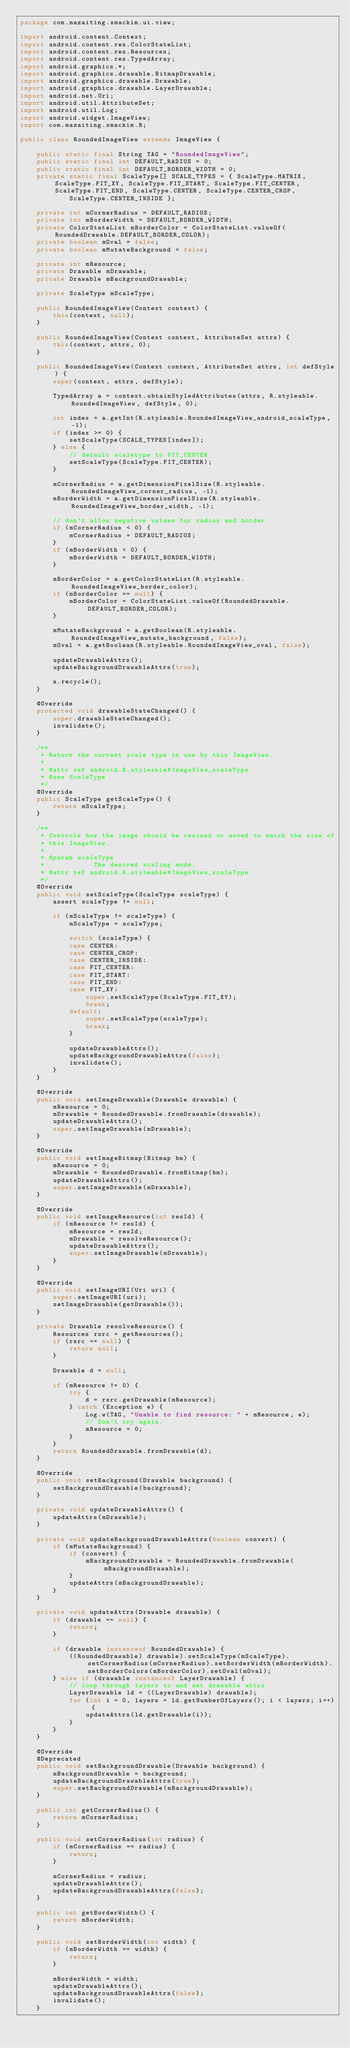Convert code to text. <code><loc_0><loc_0><loc_500><loc_500><_Java_>package com.mazaiting.smackim.ui.view;

import android.content.Context;
import android.content.res.ColorStateList;
import android.content.res.Resources;
import android.content.res.TypedArray;
import android.graphics.*;
import android.graphics.drawable.BitmapDrawable;
import android.graphics.drawable.Drawable;
import android.graphics.drawable.LayerDrawable;
import android.net.Uri;
import android.util.AttributeSet;
import android.util.Log;
import android.widget.ImageView;
import com.mazaiting.smackim.R;

public class RoundedImageView extends ImageView {

	public static final String TAG = "RoundedImageView";
	public static final int DEFAULT_RADIUS = 0;
	public static final int DEFAULT_BORDER_WIDTH = 0;
	private static final ScaleType[] SCALE_TYPES = { ScaleType.MATRIX, ScaleType.FIT_XY, ScaleType.FIT_START, ScaleType.FIT_CENTER, ScaleType.FIT_END, ScaleType.CENTER, ScaleType.CENTER_CROP,
			ScaleType.CENTER_INSIDE };

	private int mCornerRadius = DEFAULT_RADIUS;
	private int mBorderWidth = DEFAULT_BORDER_WIDTH;
	private ColorStateList mBorderColor = ColorStateList.valueOf(RoundedDrawable.DEFAULT_BORDER_COLOR);
	private boolean mOval = false;
	private boolean mMutateBackground = false;

	private int mResource;
	private Drawable mDrawable;
	private Drawable mBackgroundDrawable;

	private ScaleType mScaleType;

	public RoundedImageView(Context context) {
		this(context, null);
	}

	public RoundedImageView(Context context, AttributeSet attrs) {
		this(context, attrs, 0);
	}

	public RoundedImageView(Context context, AttributeSet attrs, int defStyle) {
		super(context, attrs, defStyle);

		TypedArray a = context.obtainStyledAttributes(attrs, R.styleable.RoundedImageView, defStyle, 0);

		int index = a.getInt(R.styleable.RoundedImageView_android_scaleType, -1);
		if (index >= 0) {
			setScaleType(SCALE_TYPES[index]);
		} else {
			// default scaletype to FIT_CENTER
			setScaleType(ScaleType.FIT_CENTER);
		}

		mCornerRadius = a.getDimensionPixelSize(R.styleable.RoundedImageView_corner_radius, -1);
		mBorderWidth = a.getDimensionPixelSize(R.styleable.RoundedImageView_border_width, -1);

		// don't allow negative values for radius and border
		if (mCornerRadius < 0) {
			mCornerRadius = DEFAULT_RADIUS;
		}
		if (mBorderWidth < 0) {
			mBorderWidth = DEFAULT_BORDER_WIDTH;
		}

		mBorderColor = a.getColorStateList(R.styleable.RoundedImageView_border_color);
		if (mBorderColor == null) {
			mBorderColor = ColorStateList.valueOf(RoundedDrawable.DEFAULT_BORDER_COLOR);
		}

		mMutateBackground = a.getBoolean(R.styleable.RoundedImageView_mutate_background, false);
		mOval = a.getBoolean(R.styleable.RoundedImageView_oval, false);

		updateDrawableAttrs();
		updateBackgroundDrawableAttrs(true);

		a.recycle();
	}

	@Override
	protected void drawableStateChanged() {
		super.drawableStateChanged();
		invalidate();
	}

	/**
	 * Return the current scale type in use by this ImageView.
	 * 
	 * @attr ref android.R.styleable#ImageView_scaleType
	 * @see ScaleType
	 */
	@Override
	public ScaleType getScaleType() {
		return mScaleType;
	}

	/**
	 * Controls how the image should be resized or moved to match the size of
	 * this ImageView.
	 * 
	 * @param scaleType
	 *            The desired scaling mode.
	 * @attr ref android.R.styleable#ImageView_scaleType
	 */
	@Override
	public void setScaleType(ScaleType scaleType) {
		assert scaleType != null;

		if (mScaleType != scaleType) {
			mScaleType = scaleType;

			switch (scaleType) {
			case CENTER:
			case CENTER_CROP:
			case CENTER_INSIDE:
			case FIT_CENTER:
			case FIT_START:
			case FIT_END:
			case FIT_XY:
				super.setScaleType(ScaleType.FIT_XY);
				break;
			default:
				super.setScaleType(scaleType);
				break;
			}

			updateDrawableAttrs();
			updateBackgroundDrawableAttrs(false);
			invalidate();
		}
	}

	@Override
	public void setImageDrawable(Drawable drawable) {
		mResource = 0;
		mDrawable = RoundedDrawable.fromDrawable(drawable);
		updateDrawableAttrs();
		super.setImageDrawable(mDrawable);
	}

	@Override
	public void setImageBitmap(Bitmap bm) {
		mResource = 0;
		mDrawable = RoundedDrawable.fromBitmap(bm);
		updateDrawableAttrs();
		super.setImageDrawable(mDrawable);
	}

	@Override
	public void setImageResource(int resId) {
		if (mResource != resId) {
			mResource = resId;
			mDrawable = resolveResource();
			updateDrawableAttrs();
			super.setImageDrawable(mDrawable);
		}
	}

	@Override
	public void setImageURI(Uri uri) {
		super.setImageURI(uri);
		setImageDrawable(getDrawable());
	}

	private Drawable resolveResource() {
		Resources rsrc = getResources();
		if (rsrc == null) {
			return null;
		}

		Drawable d = null;

		if (mResource != 0) {
			try {
				d = rsrc.getDrawable(mResource);
			} catch (Exception e) {
				Log.w(TAG, "Unable to find resource: " + mResource, e);
				// Don't try again.
				mResource = 0;
			}
		}
		return RoundedDrawable.fromDrawable(d);
	}

	@Override
	public void setBackground(Drawable background) {
		setBackgroundDrawable(background);
	}

	private void updateDrawableAttrs() {
		updateAttrs(mDrawable);
	}

	private void updateBackgroundDrawableAttrs(boolean convert) {
		if (mMutateBackground) {
			if (convert) {
				mBackgroundDrawable = RoundedDrawable.fromDrawable(mBackgroundDrawable);
			}
			updateAttrs(mBackgroundDrawable);
		}
	}

	private void updateAttrs(Drawable drawable) {
		if (drawable == null) {
			return;
		}

		if (drawable instanceof RoundedDrawable) {
			((RoundedDrawable) drawable).setScaleType(mScaleType).setCornerRadius(mCornerRadius).setBorderWidth(mBorderWidth).setBorderColors(mBorderColor).setOval(mOval);
		} else if (drawable instanceof LayerDrawable) {
			// loop through layers to and set drawable attrs
			LayerDrawable ld = ((LayerDrawable) drawable);
			for (int i = 0, layers = ld.getNumberOfLayers(); i < layers; i++) {
				updateAttrs(ld.getDrawable(i));
			}
		}
	}

	@Override
	@Deprecated
	public void setBackgroundDrawable(Drawable background) {
		mBackgroundDrawable = background;
		updateBackgroundDrawableAttrs(true);
		super.setBackgroundDrawable(mBackgroundDrawable);
	}

	public int getCornerRadius() {
		return mCornerRadius;
	}

	public void setCornerRadius(int radius) {
		if (mCornerRadius == radius) {
			return;
		}

		mCornerRadius = radius;
		updateDrawableAttrs();
		updateBackgroundDrawableAttrs(false);
	}

	public int getBorderWidth() {
		return mBorderWidth;
	}

	public void setBorderWidth(int width) {
		if (mBorderWidth == width) {
			return;
		}

		mBorderWidth = width;
		updateDrawableAttrs();
		updateBackgroundDrawableAttrs(false);
		invalidate();
	}
</code> 